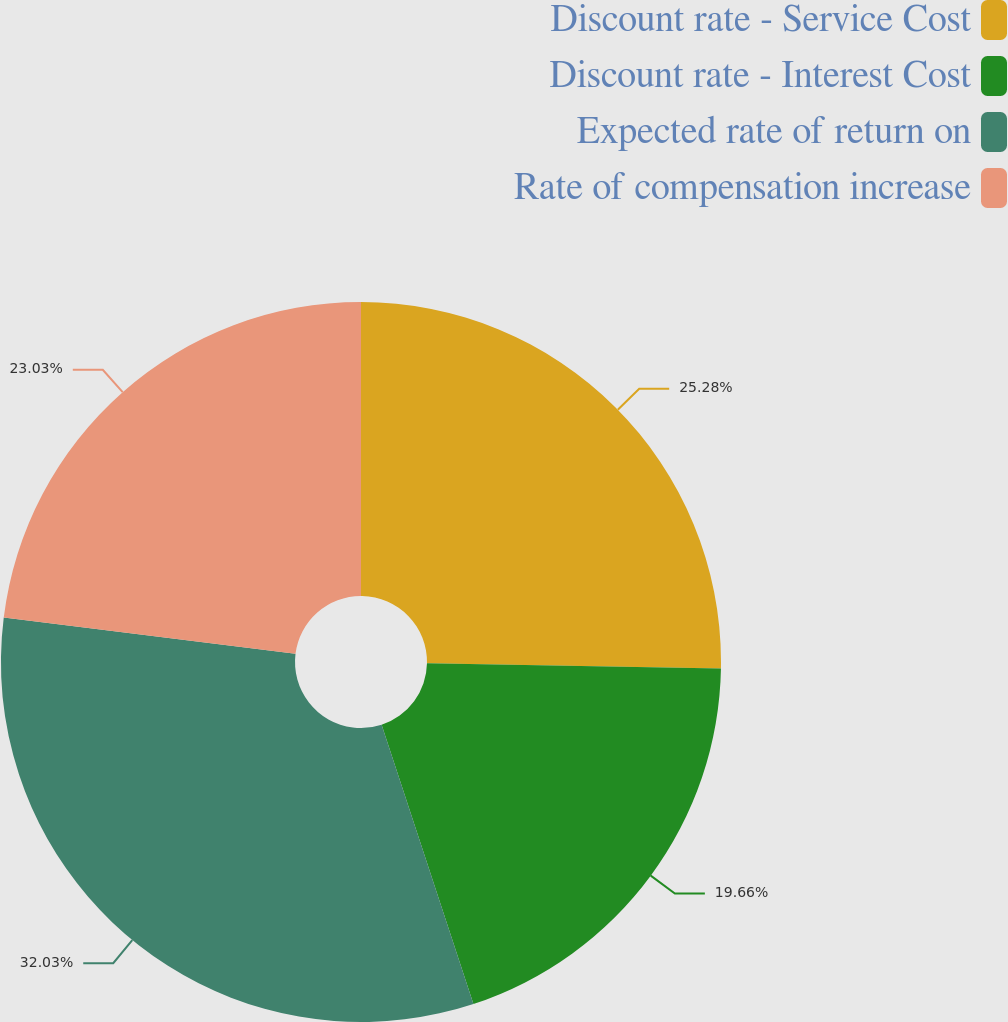Convert chart to OTSL. <chart><loc_0><loc_0><loc_500><loc_500><pie_chart><fcel>Discount rate - Service Cost<fcel>Discount rate - Interest Cost<fcel>Expected rate of return on<fcel>Rate of compensation increase<nl><fcel>25.28%<fcel>19.66%<fcel>32.02%<fcel>23.03%<nl></chart> 